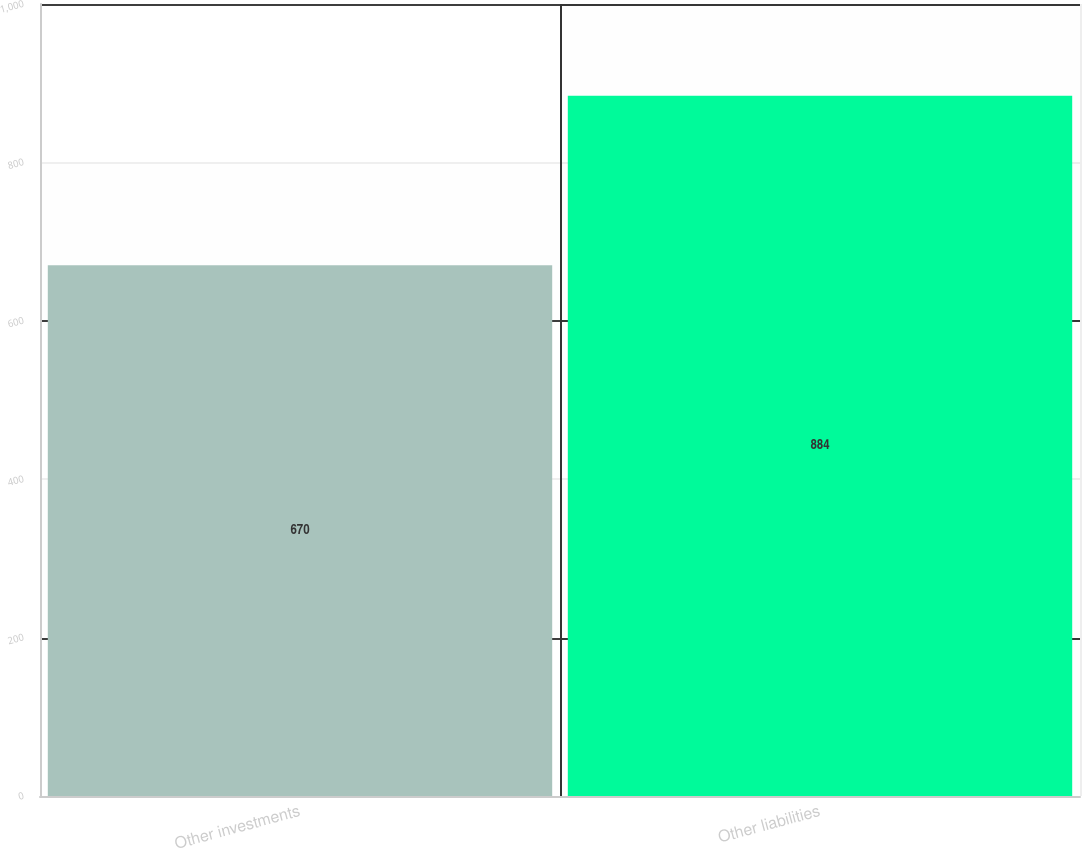Convert chart. <chart><loc_0><loc_0><loc_500><loc_500><bar_chart><fcel>Other investments<fcel>Other liabilities<nl><fcel>670<fcel>884<nl></chart> 